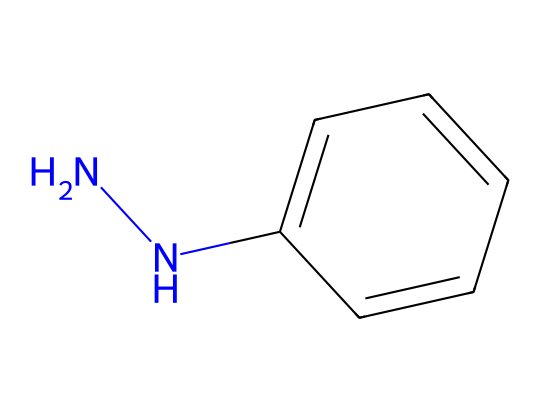What is the molecular formula of phenylhydrazine? The SMILES representation indicates the presence of two nitrogen atoms (N), one phenyl group (C6H5), and one additional nitrogen connected to the phenyl (N). Counting all the atoms gives the molecular formula C6H8N2.
Answer: C6H8N2 How many nitrogen atoms are present in phenylhydrazine? By examining the SMILES structure, there are two occurrences of the nitrogen (N) character, confirming the presence of two nitrogen atoms in the molecule.
Answer: 2 What type of compound is phenylhydrazine classified as? Phenylhydrazine contains a hydrazine group (two nitrogen atoms) connected to a phenyl ring, classifying it as a hydrazine derivative.
Answer: hydrazine What functional groups are present in phenylhydrazine? The compound contains the hydrazine functional group (-N-N-) and an aromatic phenyl group, which are both part of its chemical structure.
Answer: hydrazine, aromatic How does the arrangement of atoms in phenylhydrazine affect its properties as a corrosion inhibitor? The presence of the N-N bond and aromatic ring impacts the electronic properties and reactivity, which are essential in corrosion inhibition, aiding in the formation of protective layers on metal surfaces.
Answer: electronic properties What is the significance of the phenyl group in phenylhydrazine? The phenyl group provides stability and enhances the reactivity of phenylhydrazine, influencing its effectiveness in inhibiting corrosion through interactions with metal surfaces.
Answer: stability In what applications is phenylhydrazine primarily used? Phenylhydrazine is primarily used in organic synthesis and as a corrosion inhibitor in various industries, due to its reactive nature and ability to form protective layers.
Answer: organic synthesis, corrosion inhibitor 